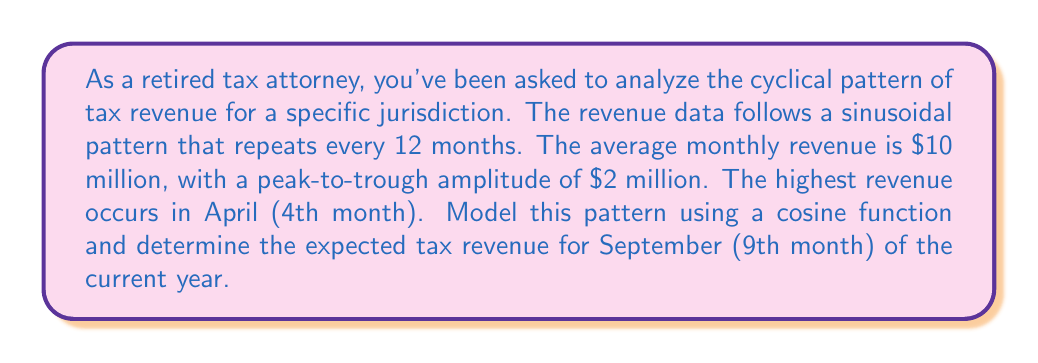Teach me how to tackle this problem. Let's approach this step-by-step:

1) The general form of a cosine function is:

   $$f(t) = A \cos(B(t-C)) + D$$

   Where:
   $A$ is the amplitude
   $B$ is the angular frequency
   $C$ is the phase shift
   $D$ is the vertical shift (average value)

2) Given information:
   - Average revenue (D): $10 million
   - Amplitude (A): $1 million (half of peak-to-trough)
   - Period: 12 months
   - Peak occurs in April (4th month)

3) Calculate B:
   $$B = \frac{2\pi}{\text{period}} = \frac{2\pi}{12} = \frac{\pi}{6}$$

4) Calculate C:
   The cosine function peaks at t = C. April is the 4th month, so C = 4.

5) Our function becomes:

   $$f(t) = 1 \cos(\frac{\pi}{6}(t-4)) + 10$$

   Where t is the month number (1 for January, 2 for February, etc.)

6) To find September's revenue, we substitute t = 9:

   $$f(9) = 1 \cos(\frac{\pi}{6}(9-4)) + 10$$
   $$f(9) = 1 \cos(\frac{5\pi}{6}) + 10$$

7) Calculate:
   $$\cos(\frac{5\pi}{6}) = -\frac{\sqrt{3}}{2} \approx -0.866$$

8) Therefore:
   $$f(9) = 1 (-0.866) + 10 = 9.134$$
Answer: The expected tax revenue for September is approximately $9.134 million. 